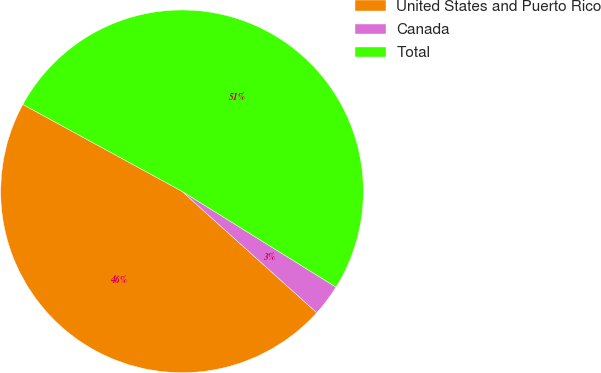<chart> <loc_0><loc_0><loc_500><loc_500><pie_chart><fcel>United States and Puerto Rico<fcel>Canada<fcel>Total<nl><fcel>46.28%<fcel>2.81%<fcel>50.91%<nl></chart> 